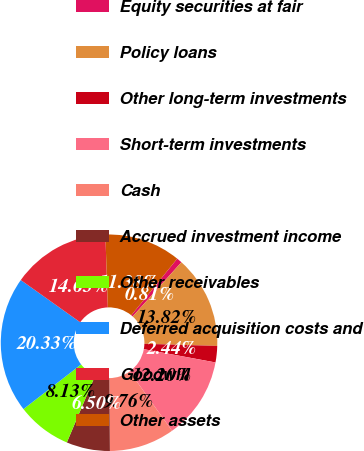Convert chart. <chart><loc_0><loc_0><loc_500><loc_500><pie_chart><fcel>Equity securities at fair<fcel>Policy loans<fcel>Other long-term investments<fcel>Short-term investments<fcel>Cash<fcel>Accrued investment income<fcel>Other receivables<fcel>Deferred acquisition costs and<fcel>Goodwill<fcel>Other assets<nl><fcel>0.81%<fcel>13.82%<fcel>2.44%<fcel>12.2%<fcel>9.76%<fcel>6.5%<fcel>8.13%<fcel>20.33%<fcel>14.63%<fcel>11.38%<nl></chart> 